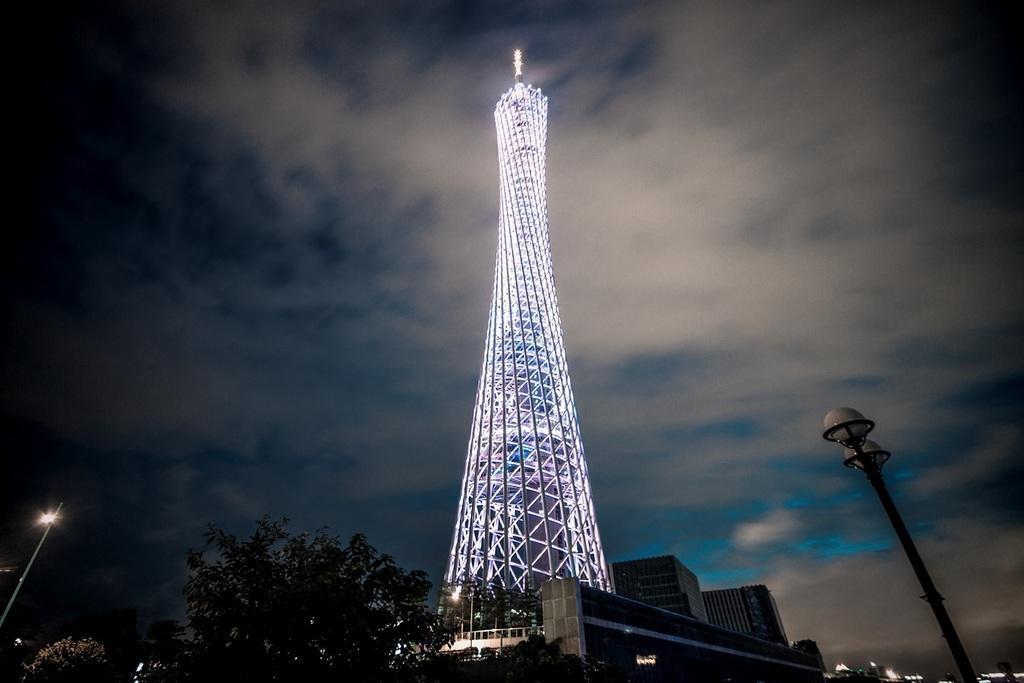Can you describe this image briefly? In the center of the image, we can see a tower with lights and there are buildings, trees, poles and street lights. At the top, there are clouds in the sky. 